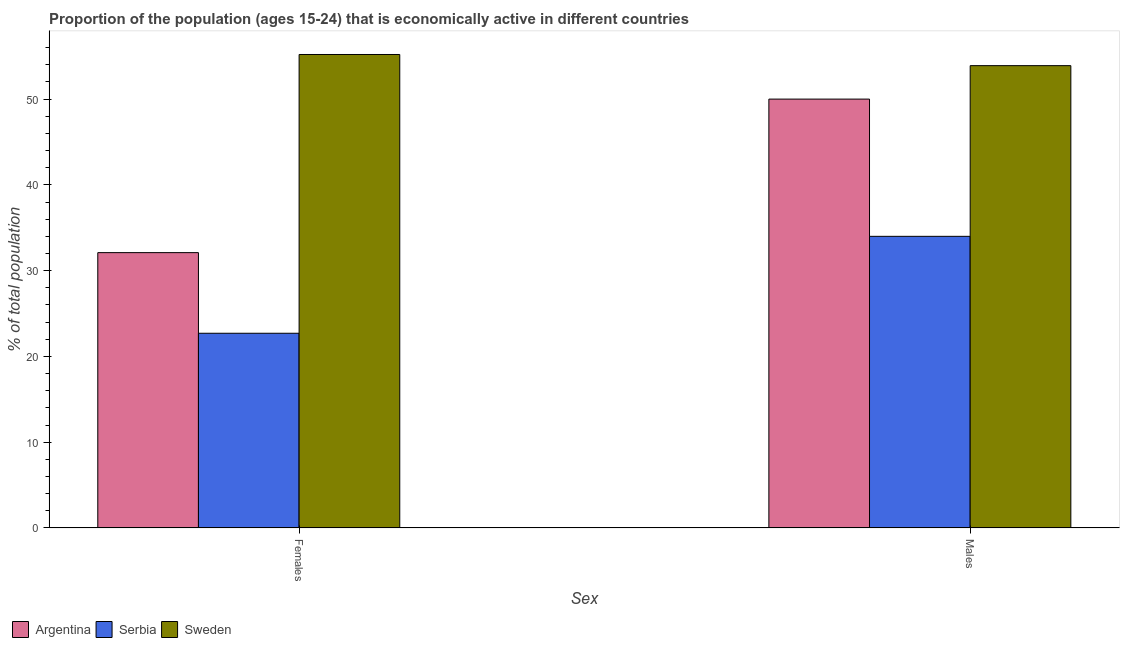How many different coloured bars are there?
Provide a short and direct response. 3. Are the number of bars per tick equal to the number of legend labels?
Provide a short and direct response. Yes. How many bars are there on the 2nd tick from the left?
Ensure brevity in your answer.  3. How many bars are there on the 2nd tick from the right?
Offer a terse response. 3. What is the label of the 1st group of bars from the left?
Your response must be concise. Females. What is the percentage of economically active female population in Sweden?
Offer a terse response. 55.2. Across all countries, what is the maximum percentage of economically active male population?
Offer a terse response. 53.9. In which country was the percentage of economically active male population maximum?
Provide a succinct answer. Sweden. In which country was the percentage of economically active male population minimum?
Ensure brevity in your answer.  Serbia. What is the total percentage of economically active female population in the graph?
Make the answer very short. 110. What is the difference between the percentage of economically active male population in Sweden and that in Serbia?
Ensure brevity in your answer.  19.9. What is the difference between the percentage of economically active female population in Sweden and the percentage of economically active male population in Serbia?
Your response must be concise. 21.2. What is the average percentage of economically active male population per country?
Provide a short and direct response. 45.97. What is the difference between the percentage of economically active male population and percentage of economically active female population in Argentina?
Ensure brevity in your answer.  17.9. In how many countries, is the percentage of economically active male population greater than 30 %?
Provide a short and direct response. 3. What is the ratio of the percentage of economically active male population in Serbia to that in Argentina?
Your response must be concise. 0.68. Is the percentage of economically active female population in Sweden less than that in Serbia?
Ensure brevity in your answer.  No. What does the 3rd bar from the left in Females represents?
Make the answer very short. Sweden. What does the 2nd bar from the right in Males represents?
Your response must be concise. Serbia. Are all the bars in the graph horizontal?
Your answer should be very brief. No. How many countries are there in the graph?
Your answer should be very brief. 3. What is the difference between two consecutive major ticks on the Y-axis?
Give a very brief answer. 10. Does the graph contain any zero values?
Make the answer very short. No. Where does the legend appear in the graph?
Keep it short and to the point. Bottom left. How many legend labels are there?
Your answer should be compact. 3. How are the legend labels stacked?
Give a very brief answer. Horizontal. What is the title of the graph?
Keep it short and to the point. Proportion of the population (ages 15-24) that is economically active in different countries. What is the label or title of the X-axis?
Your answer should be very brief. Sex. What is the label or title of the Y-axis?
Your answer should be very brief. % of total population. What is the % of total population of Argentina in Females?
Your response must be concise. 32.1. What is the % of total population in Serbia in Females?
Offer a terse response. 22.7. What is the % of total population in Sweden in Females?
Offer a very short reply. 55.2. What is the % of total population of Argentina in Males?
Provide a succinct answer. 50. What is the % of total population of Sweden in Males?
Offer a terse response. 53.9. Across all Sex, what is the maximum % of total population of Argentina?
Your answer should be compact. 50. Across all Sex, what is the maximum % of total population of Serbia?
Provide a short and direct response. 34. Across all Sex, what is the maximum % of total population in Sweden?
Keep it short and to the point. 55.2. Across all Sex, what is the minimum % of total population of Argentina?
Make the answer very short. 32.1. Across all Sex, what is the minimum % of total population of Serbia?
Give a very brief answer. 22.7. Across all Sex, what is the minimum % of total population in Sweden?
Ensure brevity in your answer.  53.9. What is the total % of total population of Argentina in the graph?
Make the answer very short. 82.1. What is the total % of total population in Serbia in the graph?
Keep it short and to the point. 56.7. What is the total % of total population of Sweden in the graph?
Offer a terse response. 109.1. What is the difference between the % of total population of Argentina in Females and that in Males?
Give a very brief answer. -17.9. What is the difference between the % of total population of Sweden in Females and that in Males?
Your answer should be compact. 1.3. What is the difference between the % of total population of Argentina in Females and the % of total population of Sweden in Males?
Provide a short and direct response. -21.8. What is the difference between the % of total population in Serbia in Females and the % of total population in Sweden in Males?
Provide a short and direct response. -31.2. What is the average % of total population in Argentina per Sex?
Give a very brief answer. 41.05. What is the average % of total population in Serbia per Sex?
Keep it short and to the point. 28.35. What is the average % of total population in Sweden per Sex?
Provide a short and direct response. 54.55. What is the difference between the % of total population of Argentina and % of total population of Sweden in Females?
Provide a succinct answer. -23.1. What is the difference between the % of total population of Serbia and % of total population of Sweden in Females?
Give a very brief answer. -32.5. What is the difference between the % of total population of Argentina and % of total population of Serbia in Males?
Offer a terse response. 16. What is the difference between the % of total population in Argentina and % of total population in Sweden in Males?
Offer a terse response. -3.9. What is the difference between the % of total population of Serbia and % of total population of Sweden in Males?
Offer a terse response. -19.9. What is the ratio of the % of total population in Argentina in Females to that in Males?
Your answer should be very brief. 0.64. What is the ratio of the % of total population of Serbia in Females to that in Males?
Provide a short and direct response. 0.67. What is the ratio of the % of total population of Sweden in Females to that in Males?
Keep it short and to the point. 1.02. What is the difference between the highest and the second highest % of total population of Serbia?
Your response must be concise. 11.3. What is the difference between the highest and the second highest % of total population in Sweden?
Your response must be concise. 1.3. What is the difference between the highest and the lowest % of total population in Serbia?
Your answer should be very brief. 11.3. 